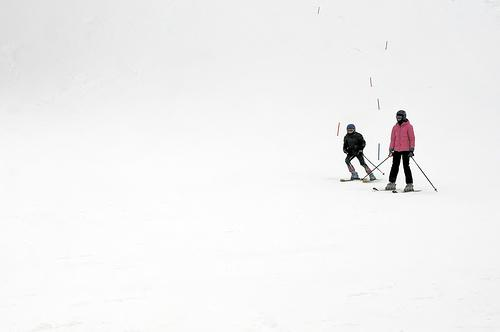Why are sticks stuck into the snow? Please explain your reasoning. guidance. They show how steep the hill is. they provide a path for skiiers. 